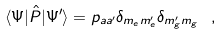Convert formula to latex. <formula><loc_0><loc_0><loc_500><loc_500>\langle \Psi | \hat { P } | \Psi ^ { \prime } \rangle = p _ { a a ^ { \prime } } \delta _ { m _ { e } m _ { e } ^ { \prime } } \delta _ { m ^ { \prime } _ { g } m _ { g } } \ ,</formula> 